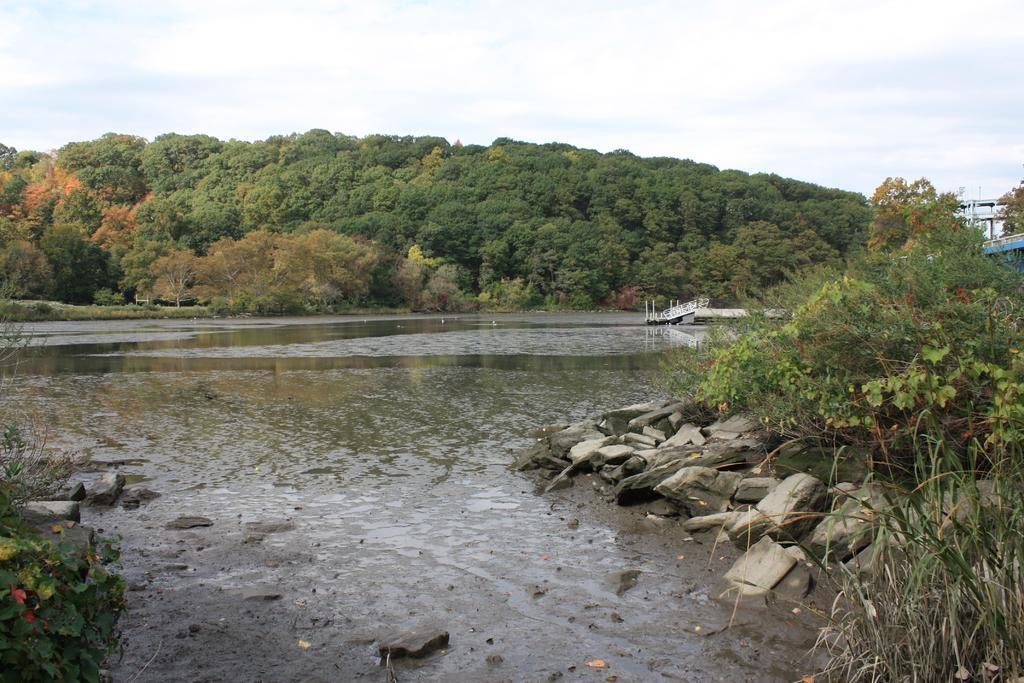Please provide a concise description of this image. This picture might be taken outside of the city. In this image, on the right side, we can see some plants and trees, bridge and a building, we can also see a boat drowning on the water. On the left side, we can also see some plants with flowers. In the background, we can see some trees. On the top there is a sky, at the bottom, we can see water and some stones. 